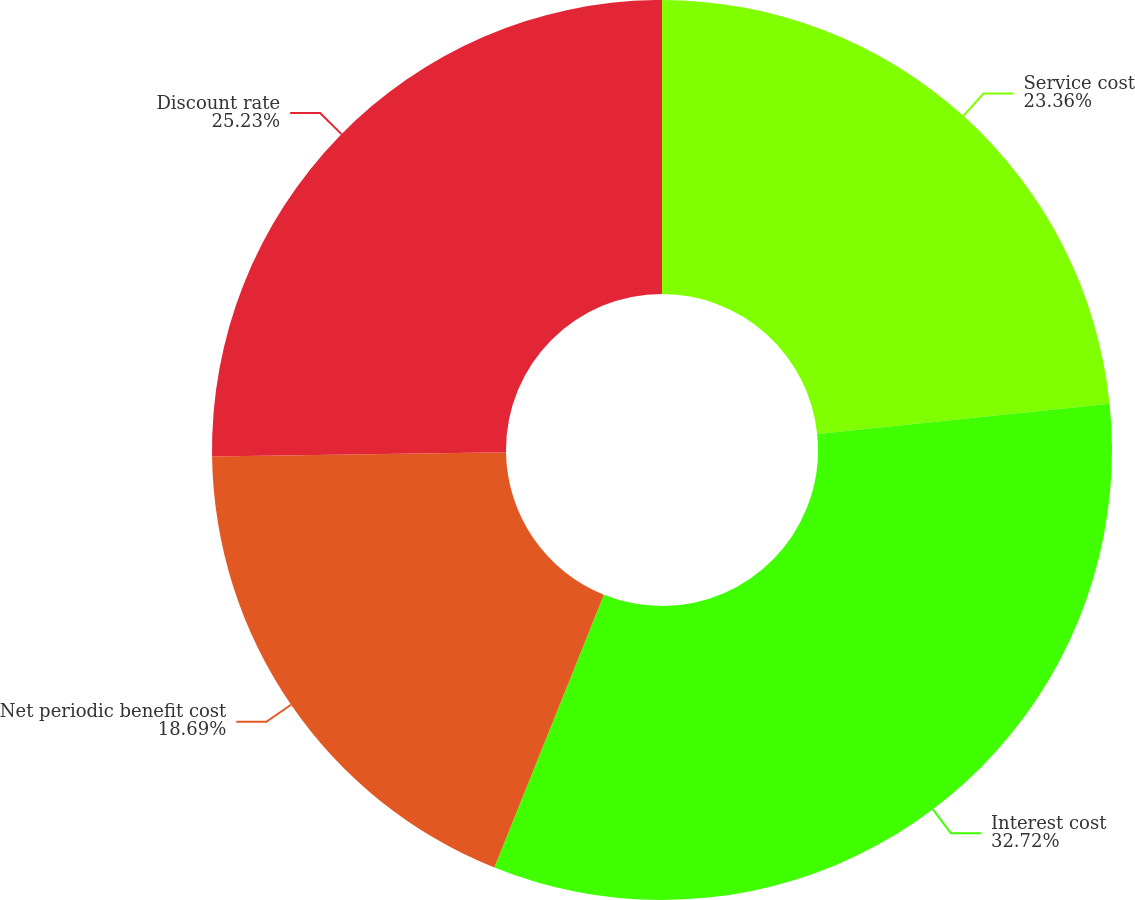Convert chart. <chart><loc_0><loc_0><loc_500><loc_500><pie_chart><fcel>Service cost<fcel>Interest cost<fcel>Net periodic benefit cost<fcel>Discount rate<nl><fcel>23.36%<fcel>32.71%<fcel>18.69%<fcel>25.23%<nl></chart> 